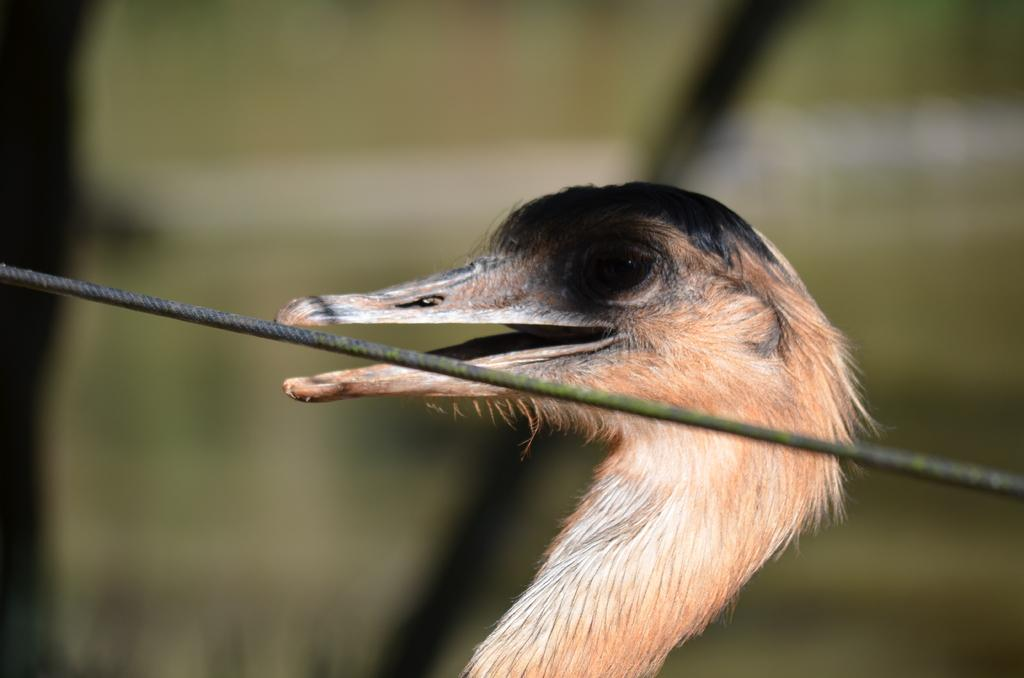What is located in the middle of the image? There is a thread in the middle of the image. What can be seen behind the thread? There is a bird behind the thread. What is the bird doing in the image? The bird has its mouth open. How would you describe the background of the image? The background of the image is blurred. What type of machine can be seen producing cakes in the image? There is no machine or cake production visible in the image; it features a thread and a bird. Can you describe the airplane that is flying in the background of the image? There is no airplane present in the image; it only contains a thread, a bird, and a blurred background. 